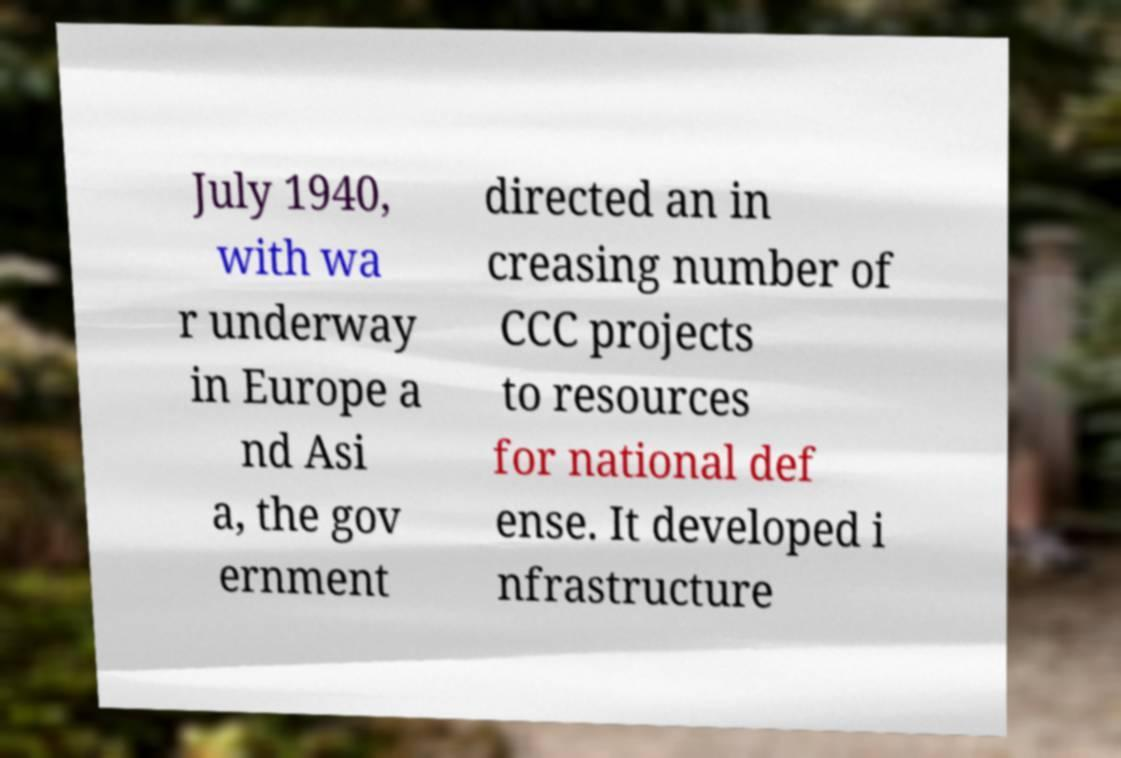Can you accurately transcribe the text from the provided image for me? July 1940, with wa r underway in Europe a nd Asi a, the gov ernment directed an in creasing number of CCC projects to resources for national def ense. It developed i nfrastructure 